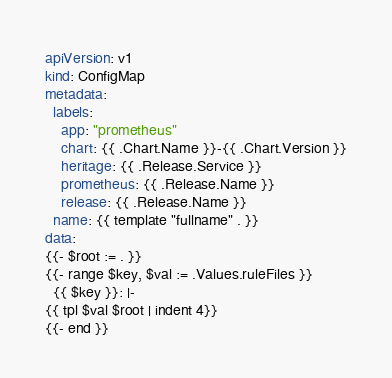<code> <loc_0><loc_0><loc_500><loc_500><_YAML_>apiVersion: v1
kind: ConfigMap
metadata:
  labels:
    app: "prometheus"
    chart: {{ .Chart.Name }}-{{ .Chart.Version }}
    heritage: {{ .Release.Service }}
    prometheus: {{ .Release.Name }}
    release: {{ .Release.Name }}
  name: {{ template "fullname" . }}
data:
{{- $root := . }}
{{- range $key, $val := .Values.ruleFiles }}
  {{ $key }}: |-
{{ tpl $val $root | indent 4}}
{{- end }}
</code> 